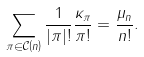Convert formula to latex. <formula><loc_0><loc_0><loc_500><loc_500>\sum _ { \pi \in \mathcal { C } \left ( n \right ) } \frac { 1 } { | \pi | ! } \frac { \kappa _ { \pi } } { \pi ! } = \frac { \mu _ { n } } { n ! } .</formula> 